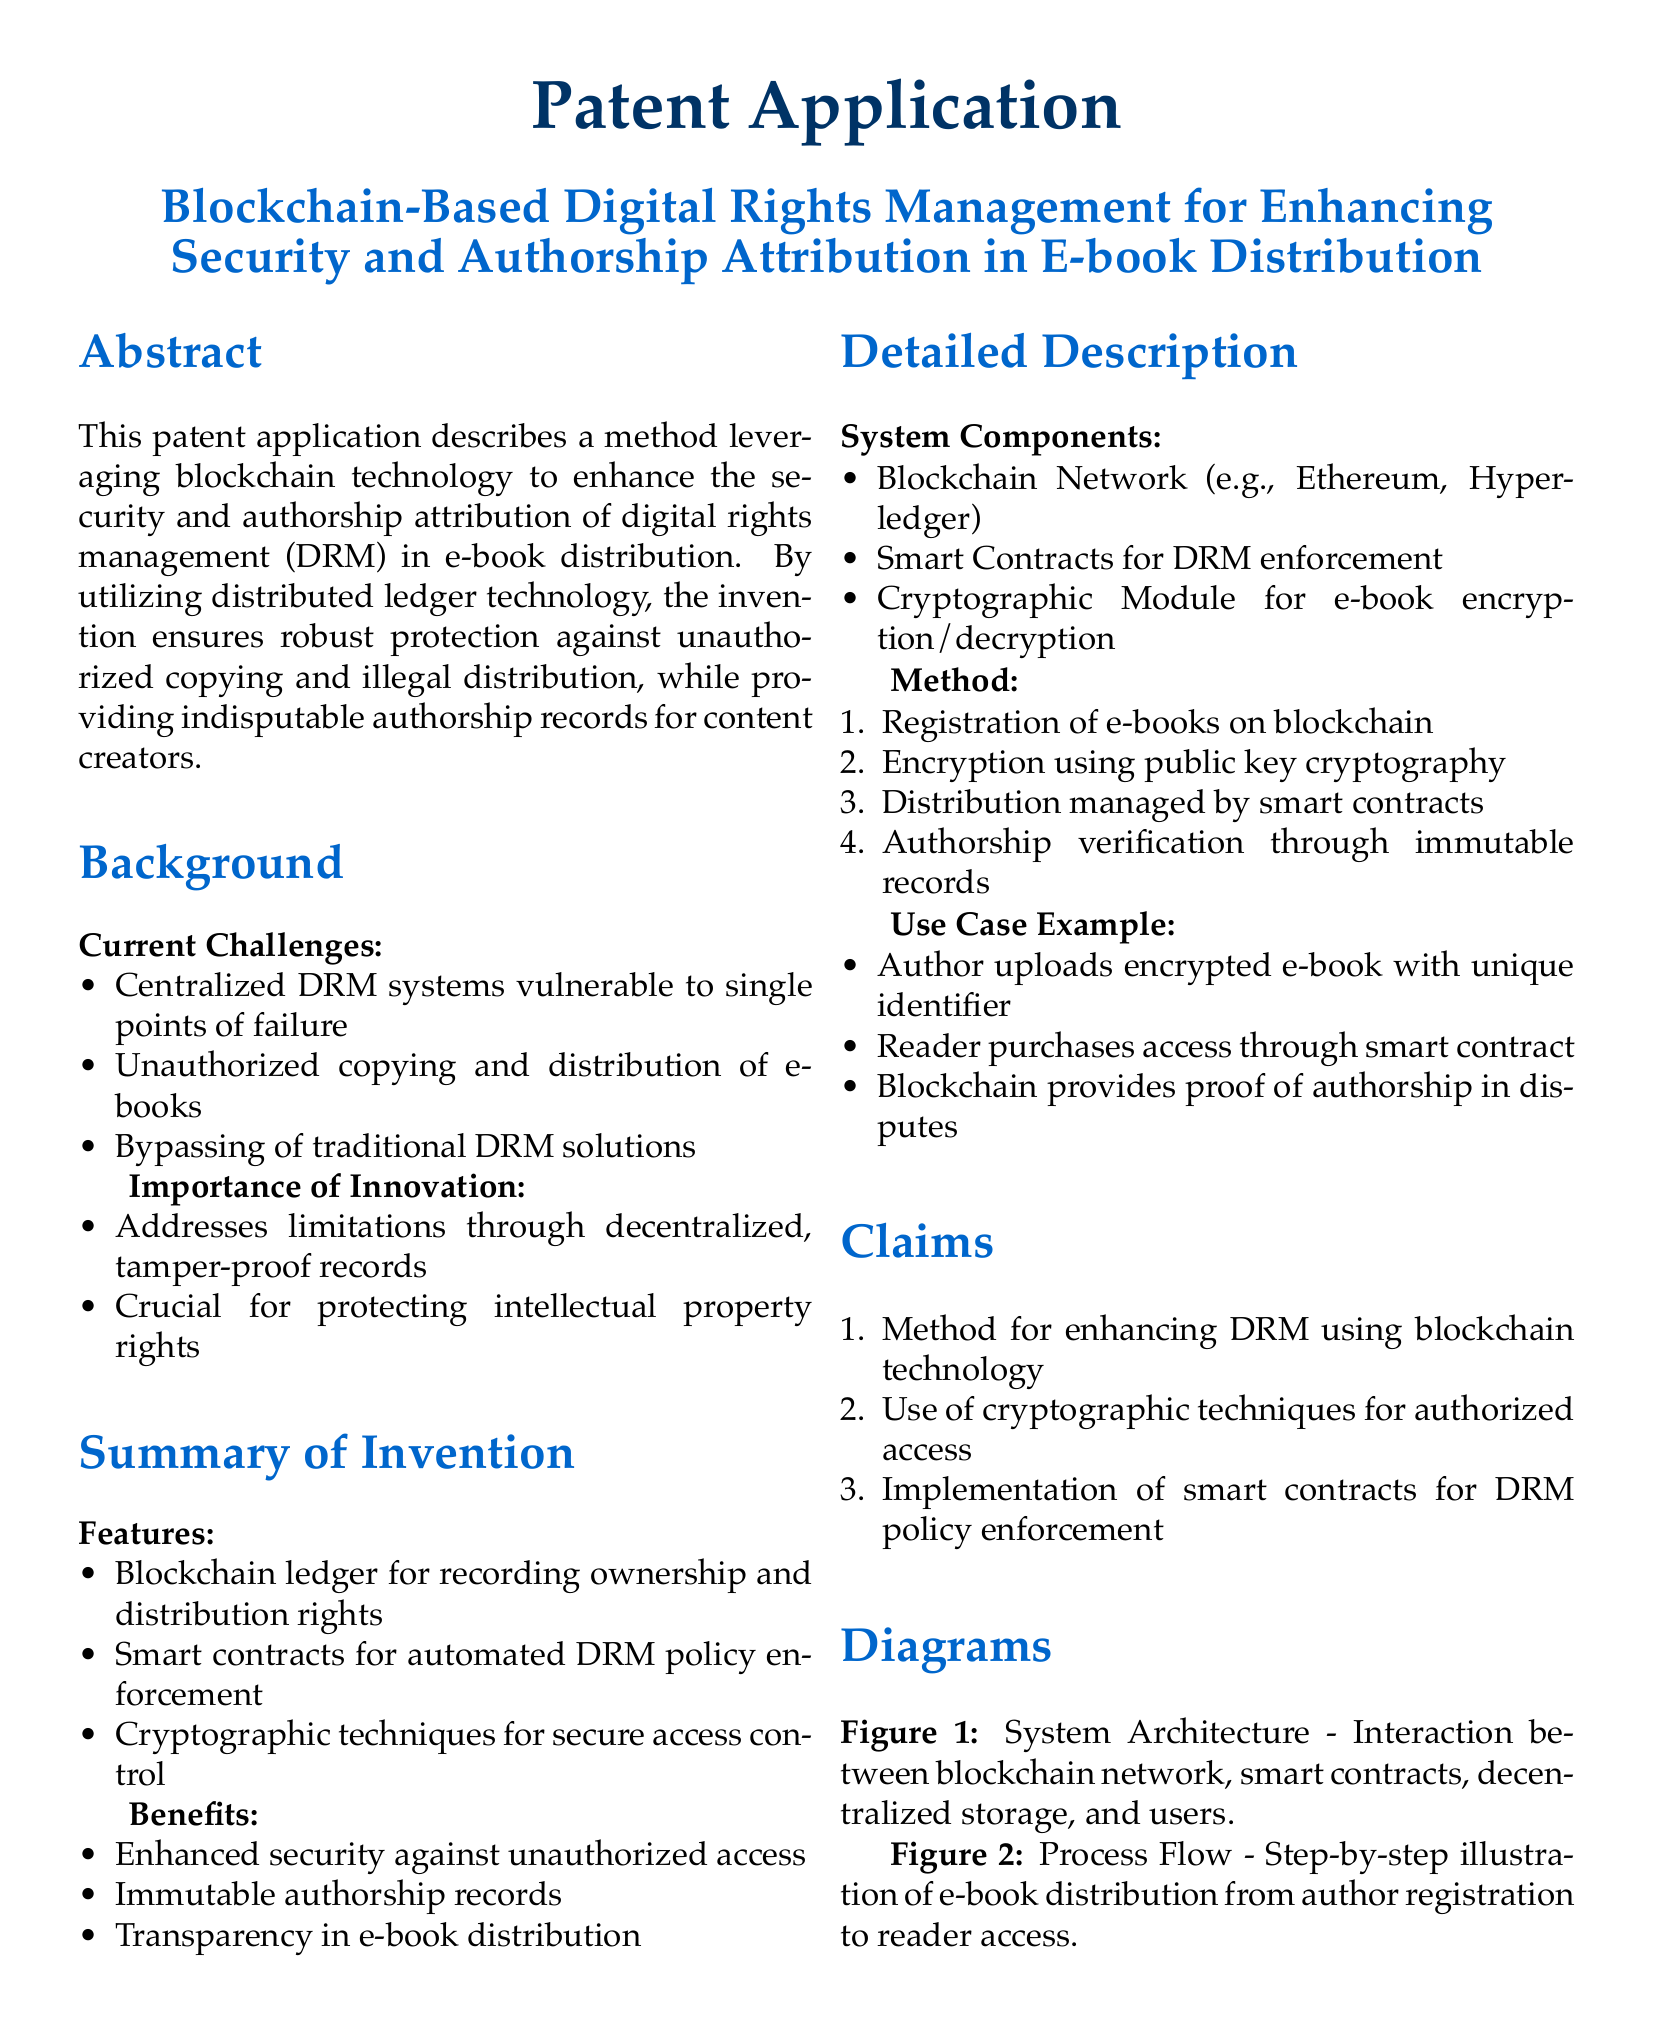What is the title of the patent application? The title of the patent application is specified in the document.
Answer: Blockchain-Based Digital Rights Management for Enhancing Security and Authorship Attribution in E-book Distribution What technology does the invention leverage? The technology leveraged in the invention is mentioned in the abstract and background sections.
Answer: Blockchain What are the current challenges in DRM systems? The current challenges are listed under the Background section.
Answer: Centralized DRM systems vulnerable to single points of failure What is one feature of the proposed invention? The features of the invention are outlined in the Summary of Invention section.
Answer: Blockchain ledger for recording ownership and distribution rights Name one benefit of the system described. Benefits of the system are detailed in the Summary of Invention section.
Answer: Enhanced security against unauthorized access What is the first step in the method described? The method steps are enumerated in the Detailed Description section.
Answer: Registration of e-books on blockchain What type of contracts are utilized for DRM enforcement? The type of contracts mentioned in the claims section for DRM enforcement is specified.
Answer: Smart contracts How does the invention ensure authorship verification? The method of authorship verification is explained in the Detailed Description section.
Answer: Immutable records What is a use case example described in the patent application? An example is provided in the Detailed Description section highlighting the interaction between author and reader.
Answer: Author uploads encrypted e-book with unique identifier What does the first claim of the invention pertain to? The claims section lists the focus of each claim related to the invention.
Answer: Method for enhancing DRM using blockchain technology 